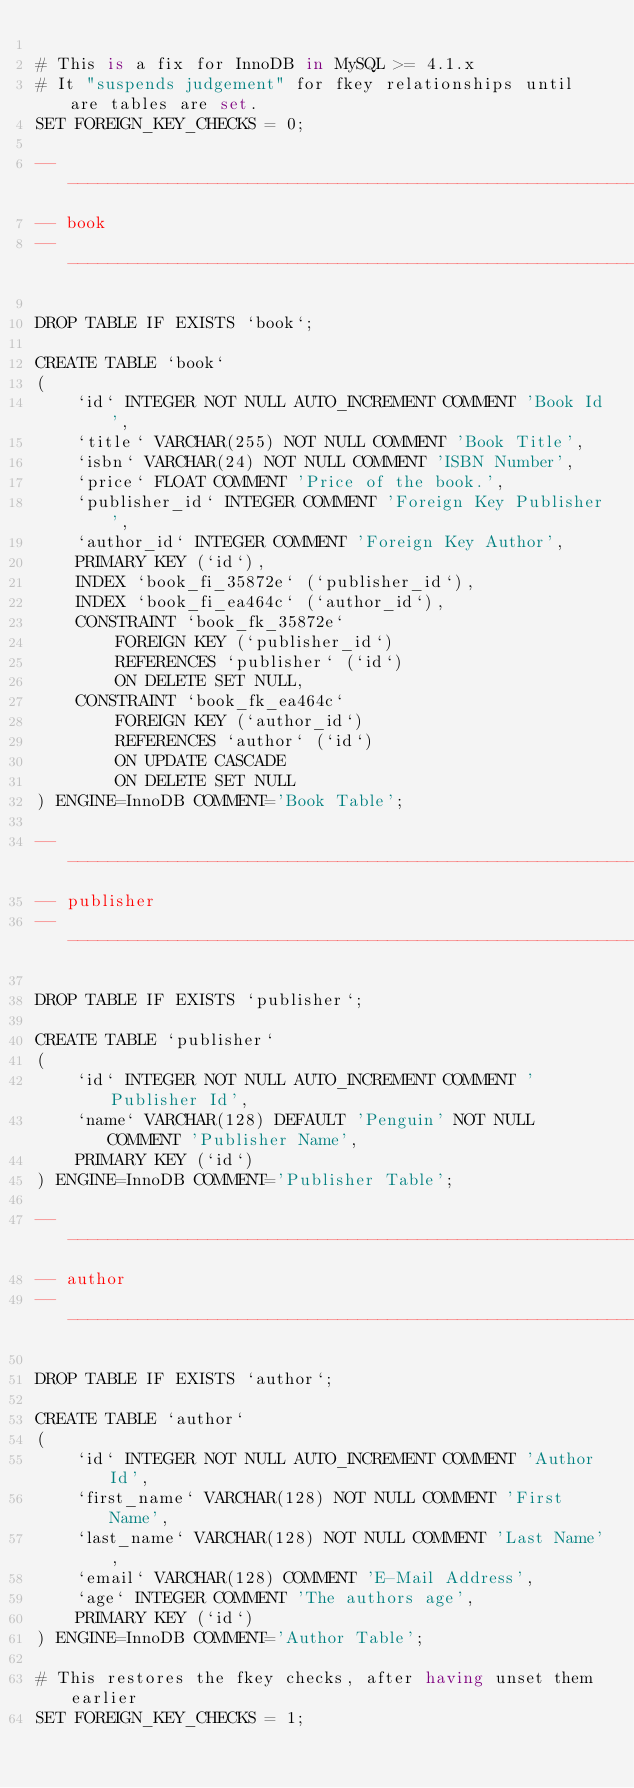Convert code to text. <code><loc_0><loc_0><loc_500><loc_500><_SQL_>
# This is a fix for InnoDB in MySQL >= 4.1.x
# It "suspends judgement" for fkey relationships until are tables are set.
SET FOREIGN_KEY_CHECKS = 0;

-- ---------------------------------------------------------------------
-- book
-- ---------------------------------------------------------------------

DROP TABLE IF EXISTS `book`;

CREATE TABLE `book`
(
    `id` INTEGER NOT NULL AUTO_INCREMENT COMMENT 'Book Id',
    `title` VARCHAR(255) NOT NULL COMMENT 'Book Title',
    `isbn` VARCHAR(24) NOT NULL COMMENT 'ISBN Number',
    `price` FLOAT COMMENT 'Price of the book.',
    `publisher_id` INTEGER COMMENT 'Foreign Key Publisher',
    `author_id` INTEGER COMMENT 'Foreign Key Author',
    PRIMARY KEY (`id`),
    INDEX `book_fi_35872e` (`publisher_id`),
    INDEX `book_fi_ea464c` (`author_id`),
    CONSTRAINT `book_fk_35872e`
        FOREIGN KEY (`publisher_id`)
        REFERENCES `publisher` (`id`)
        ON DELETE SET NULL,
    CONSTRAINT `book_fk_ea464c`
        FOREIGN KEY (`author_id`)
        REFERENCES `author` (`id`)
        ON UPDATE CASCADE
        ON DELETE SET NULL
) ENGINE=InnoDB COMMENT='Book Table';

-- ---------------------------------------------------------------------
-- publisher
-- ---------------------------------------------------------------------

DROP TABLE IF EXISTS `publisher`;

CREATE TABLE `publisher`
(
    `id` INTEGER NOT NULL AUTO_INCREMENT COMMENT 'Publisher Id',
    `name` VARCHAR(128) DEFAULT 'Penguin' NOT NULL COMMENT 'Publisher Name',
    PRIMARY KEY (`id`)
) ENGINE=InnoDB COMMENT='Publisher Table';

-- ---------------------------------------------------------------------
-- author
-- ---------------------------------------------------------------------

DROP TABLE IF EXISTS `author`;

CREATE TABLE `author`
(
    `id` INTEGER NOT NULL AUTO_INCREMENT COMMENT 'Author Id',
    `first_name` VARCHAR(128) NOT NULL COMMENT 'First Name',
    `last_name` VARCHAR(128) NOT NULL COMMENT 'Last Name',
    `email` VARCHAR(128) COMMENT 'E-Mail Address',
    `age` INTEGER COMMENT 'The authors age',
    PRIMARY KEY (`id`)
) ENGINE=InnoDB COMMENT='Author Table';

# This restores the fkey checks, after having unset them earlier
SET FOREIGN_KEY_CHECKS = 1;
</code> 